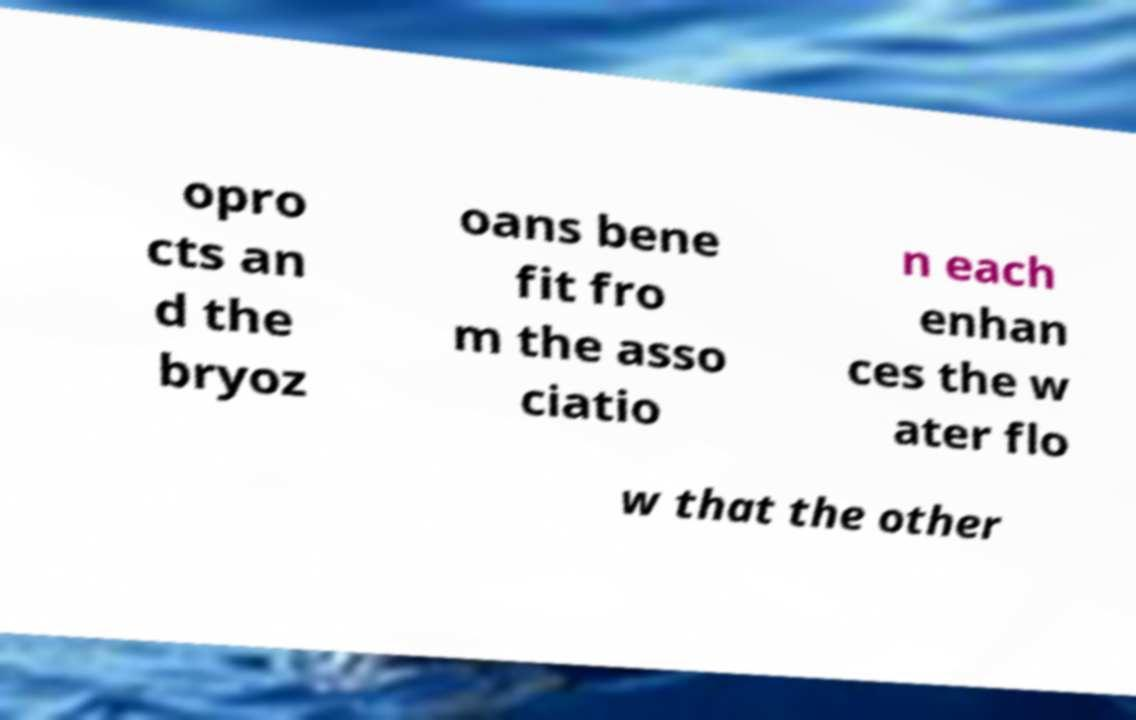Please read and relay the text visible in this image. What does it say? opro cts an d the bryoz oans bene fit fro m the asso ciatio n each enhan ces the w ater flo w that the other 